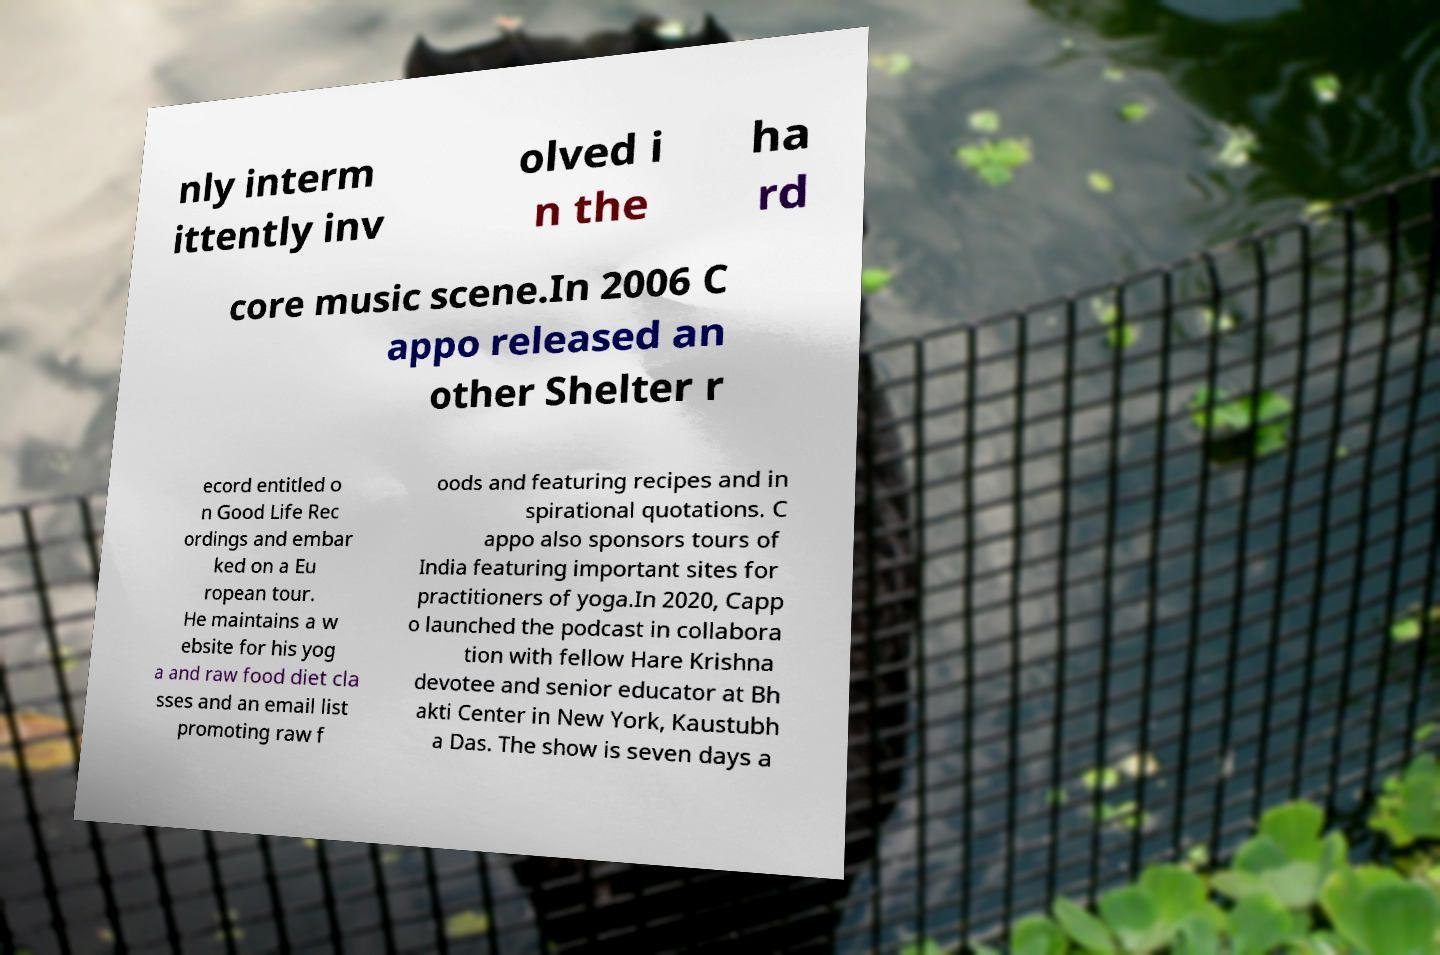Please identify and transcribe the text found in this image. nly interm ittently inv olved i n the ha rd core music scene.In 2006 C appo released an other Shelter r ecord entitled o n Good Life Rec ordings and embar ked on a Eu ropean tour. He maintains a w ebsite for his yog a and raw food diet cla sses and an email list promoting raw f oods and featuring recipes and in spirational quotations. C appo also sponsors tours of India featuring important sites for practitioners of yoga.In 2020, Capp o launched the podcast in collabora tion with fellow Hare Krishna devotee and senior educator at Bh akti Center in New York, Kaustubh a Das. The show is seven days a 